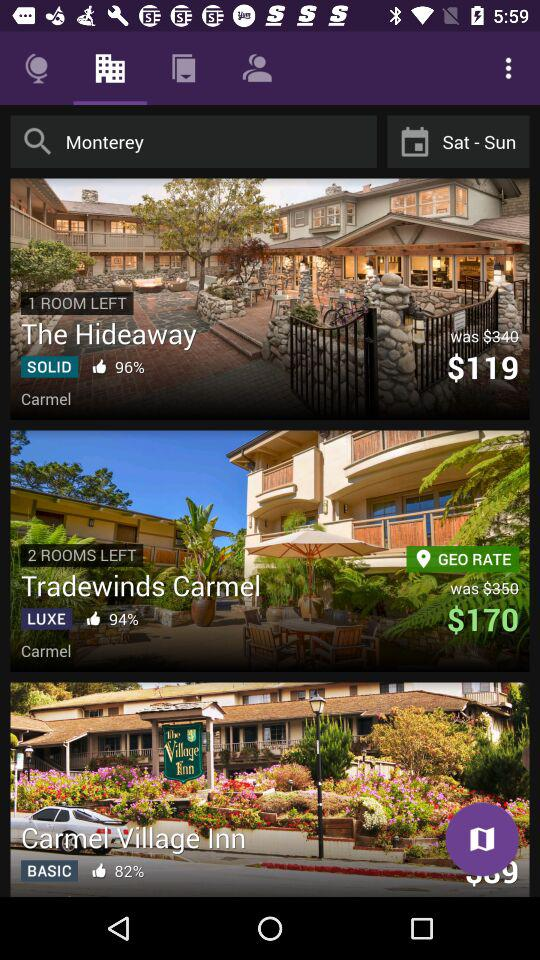What is the number of rooms left in "Tradewinds Carmel"? The number of rooms left in "Tradewinds Carmel" is 2. 